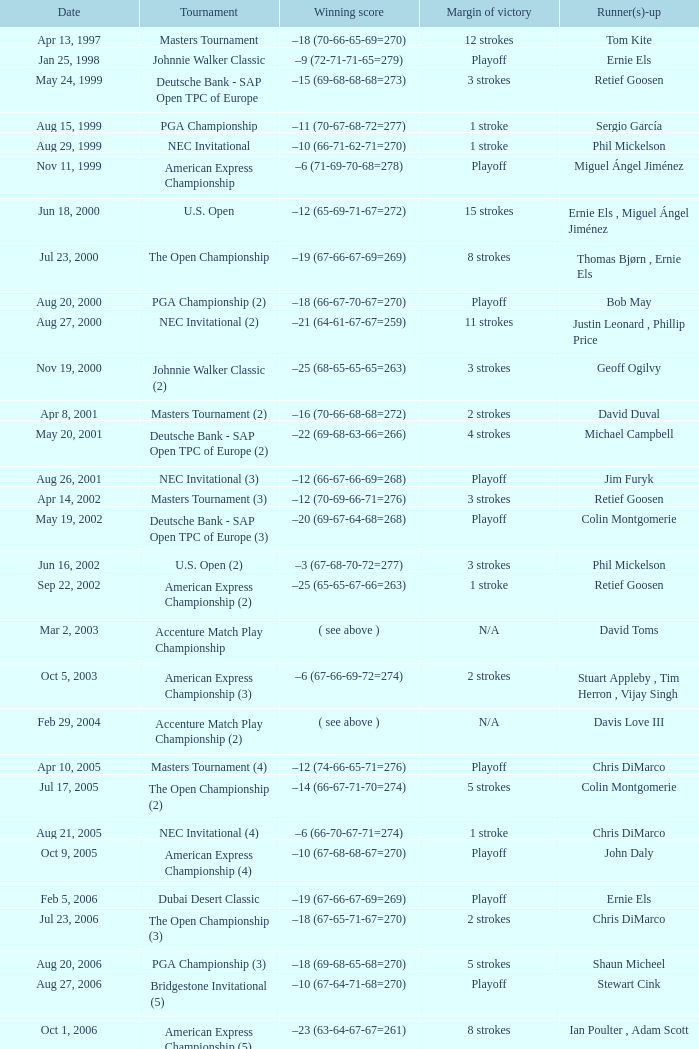Which Tournament has a Margin of victory of 7 strokes Bridgestone Invitational (8). Write the full table. {'header': ['Date', 'Tournament', 'Winning score', 'Margin of victory', 'Runner(s)-up'], 'rows': [['Apr 13, 1997', 'Masters Tournament', '–18 (70-66-65-69=270)', '12 strokes', 'Tom Kite'], ['Jan 25, 1998', 'Johnnie Walker Classic', '–9 (72-71-71-65=279)', 'Playoff', 'Ernie Els'], ['May 24, 1999', 'Deutsche Bank - SAP Open TPC of Europe', '–15 (69-68-68-68=273)', '3 strokes', 'Retief Goosen'], ['Aug 15, 1999', 'PGA Championship', '–11 (70-67-68-72=277)', '1 stroke', 'Sergio García'], ['Aug 29, 1999', 'NEC Invitational', '–10 (66-71-62-71=270)', '1 stroke', 'Phil Mickelson'], ['Nov 11, 1999', 'American Express Championship', '–6 (71-69-70-68=278)', 'Playoff', 'Miguel Ángel Jiménez'], ['Jun 18, 2000', 'U.S. Open', '–12 (65-69-71-67=272)', '15 strokes', 'Ernie Els , Miguel Ángel Jiménez'], ['Jul 23, 2000', 'The Open Championship', '–19 (67-66-67-69=269)', '8 strokes', 'Thomas Bjørn , Ernie Els'], ['Aug 20, 2000', 'PGA Championship (2)', '–18 (66-67-70-67=270)', 'Playoff', 'Bob May'], ['Aug 27, 2000', 'NEC Invitational (2)', '–21 (64-61-67-67=259)', '11 strokes', 'Justin Leonard , Phillip Price'], ['Nov 19, 2000', 'Johnnie Walker Classic (2)', '–25 (68-65-65-65=263)', '3 strokes', 'Geoff Ogilvy'], ['Apr 8, 2001', 'Masters Tournament (2)', '–16 (70-66-68-68=272)', '2 strokes', 'David Duval'], ['May 20, 2001', 'Deutsche Bank - SAP Open TPC of Europe (2)', '–22 (69-68-63-66=266)', '4 strokes', 'Michael Campbell'], ['Aug 26, 2001', 'NEC Invitational (3)', '–12 (66-67-66-69=268)', 'Playoff', 'Jim Furyk'], ['Apr 14, 2002', 'Masters Tournament (3)', '–12 (70-69-66-71=276)', '3 strokes', 'Retief Goosen'], ['May 19, 2002', 'Deutsche Bank - SAP Open TPC of Europe (3)', '–20 (69-67-64-68=268)', 'Playoff', 'Colin Montgomerie'], ['Jun 16, 2002', 'U.S. Open (2)', '–3 (67-68-70-72=277)', '3 strokes', 'Phil Mickelson'], ['Sep 22, 2002', 'American Express Championship (2)', '–25 (65-65-67-66=263)', '1 stroke', 'Retief Goosen'], ['Mar 2, 2003', 'Accenture Match Play Championship', '( see above )', 'N/A', 'David Toms'], ['Oct 5, 2003', 'American Express Championship (3)', '–6 (67-66-69-72=274)', '2 strokes', 'Stuart Appleby , Tim Herron , Vijay Singh'], ['Feb 29, 2004', 'Accenture Match Play Championship (2)', '( see above )', 'N/A', 'Davis Love III'], ['Apr 10, 2005', 'Masters Tournament (4)', '–12 (74-66-65-71=276)', 'Playoff', 'Chris DiMarco'], ['Jul 17, 2005', 'The Open Championship (2)', '–14 (66-67-71-70=274)', '5 strokes', 'Colin Montgomerie'], ['Aug 21, 2005', 'NEC Invitational (4)', '–6 (66-70-67-71=274)', '1 stroke', 'Chris DiMarco'], ['Oct 9, 2005', 'American Express Championship (4)', '–10 (67-68-68-67=270)', 'Playoff', 'John Daly'], ['Feb 5, 2006', 'Dubai Desert Classic', '–19 (67-66-67-69=269)', 'Playoff', 'Ernie Els'], ['Jul 23, 2006', 'The Open Championship (3)', '–18 (67-65-71-67=270)', '2 strokes', 'Chris DiMarco'], ['Aug 20, 2006', 'PGA Championship (3)', '–18 (69-68-65-68=270)', '5 strokes', 'Shaun Micheel'], ['Aug 27, 2006', 'Bridgestone Invitational (5)', '–10 (67-64-71-68=270)', 'Playoff', 'Stewart Cink'], ['Oct 1, 2006', 'American Express Championship (5)', '–23 (63-64-67-67=261)', '8 strokes', 'Ian Poulter , Adam Scott'], ['Mar 25, 2007', 'CA Championship (6)', '–10 (71-66-68-73=278)', '2 strokes', 'Brett Wetterich'], ['Aug 5, 2007', 'Bridgestone Invitational (6)', '−8 (68-70-69-65=272)', '8 strokes', 'Justin Rose , Rory Sabbatini'], ['Aug 12, 2007', 'PGA Championship (4)', '–8 (71-63-69-69=272)', '2 strokes', 'Woody Austin'], ['Feb 3, 2008', 'Dubai Desert Classic (2)', '–14 (65-71-73-65=274)', '1 stroke', 'Martin Kaymer'], ['Feb 24, 2008', 'Accenture Match Play Championship (3)', '( see above )', 'N/A', 'Stewart Cink'], ['Jun 16, 2008', 'U.S. Open (3)', '–1 (72-68-70-73=283)', 'Playoff', 'Rocco Mediate'], ['Aug 9, 2009', 'Bridgestone Invitational (7)', '−12 (68-70-65-65=268)', '4 strokes', 'Robert Allenby , Pádraig Harrington'], ['Nov 15, 2009', 'JBWere Masters', '–14 (66-68-72-68=274)', '2 strokes', 'Greg Chalmers'], ['Mar 10, 2013', 'Cadillac Championship (7)', '–19 (66-65-67-71=269)', '2 strokes', 'Steve Stricker'], ['Aug 4, 2013', 'Bridgestone Invitational (8)', '−15 (66-61-68-70=265)', '7 strokes', 'Keegan Bradley , Henrik Stenson']]} 